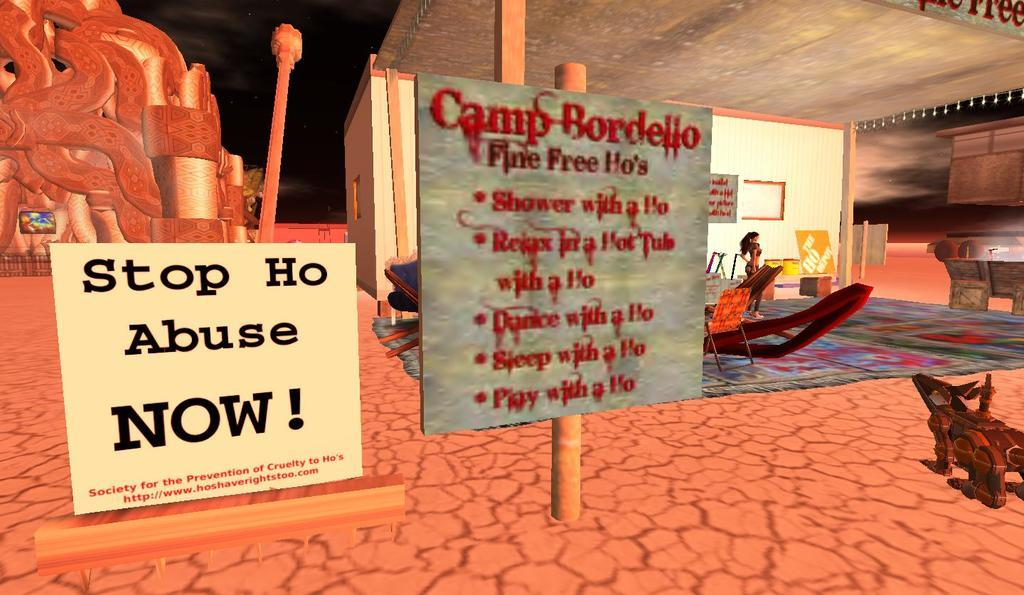<image>
Provide a brief description of the given image. A sign for Camp Bordello has another sign next to it that says Stop The Abuse Now. 